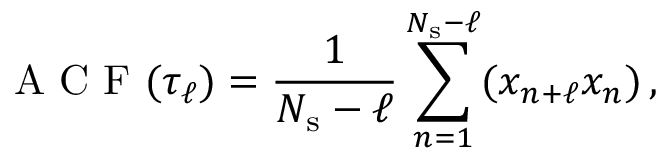Convert formula to latex. <formula><loc_0><loc_0><loc_500><loc_500>A C F ( \tau _ { \ell } ) = \frac { 1 } { N _ { s } - \ell } \sum _ { n = 1 } ^ { N _ { s } - \ell } ( x _ { n + \ell } x _ { n } ) \, ,</formula> 